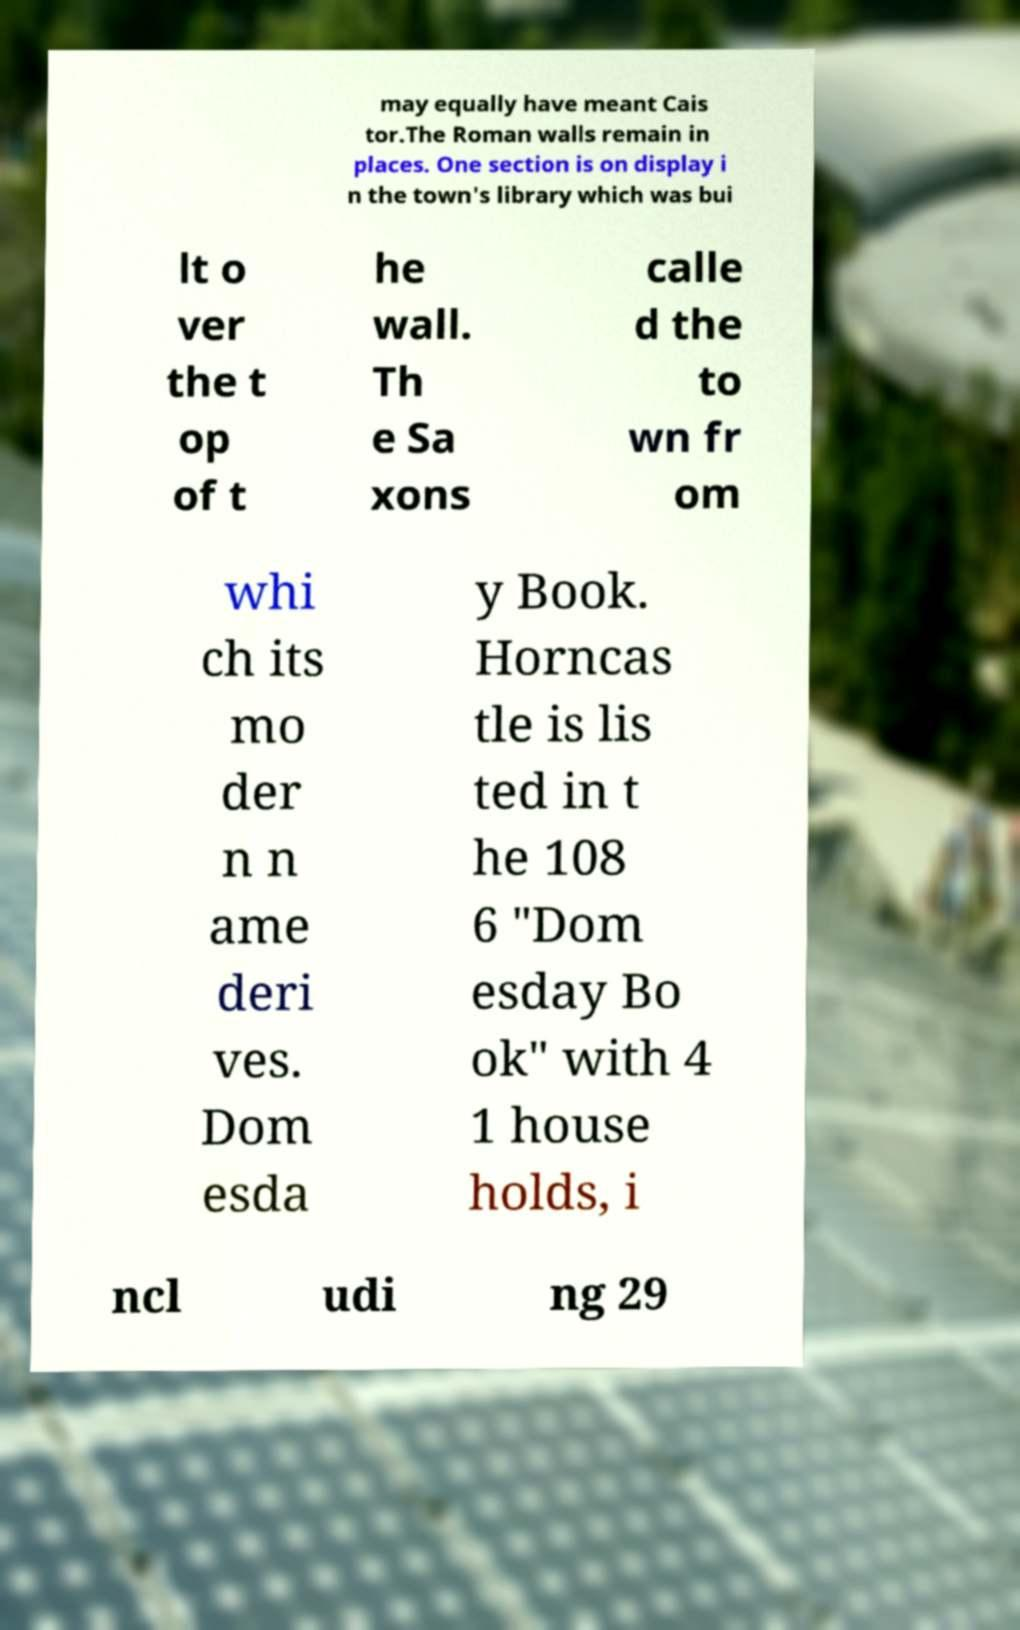What messages or text are displayed in this image? I need them in a readable, typed format. may equally have meant Cais tor.The Roman walls remain in places. One section is on display i n the town's library which was bui lt o ver the t op of t he wall. Th e Sa xons calle d the to wn fr om whi ch its mo der n n ame deri ves. Dom esda y Book. Horncas tle is lis ted in t he 108 6 "Dom esday Bo ok" with 4 1 house holds, i ncl udi ng 29 